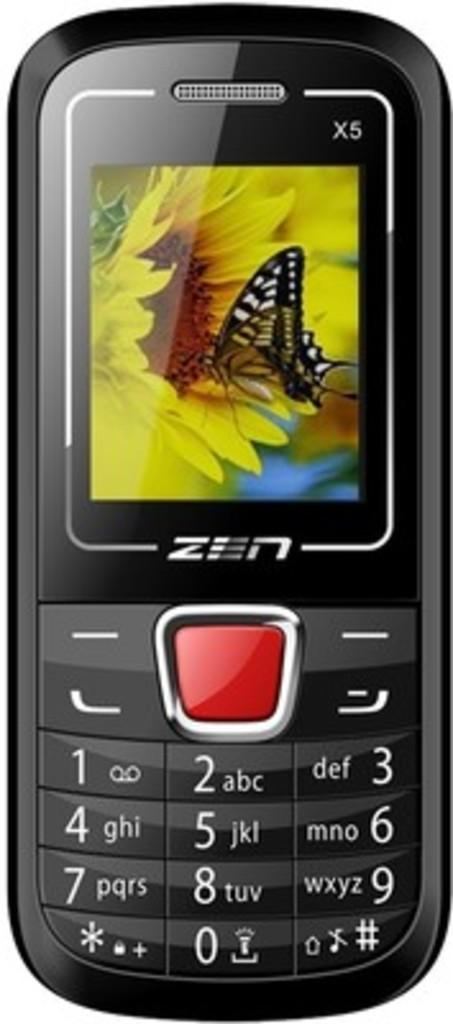<image>
Summarize the visual content of the image. a zen 5x cell phone with a butterfly on its home screen 